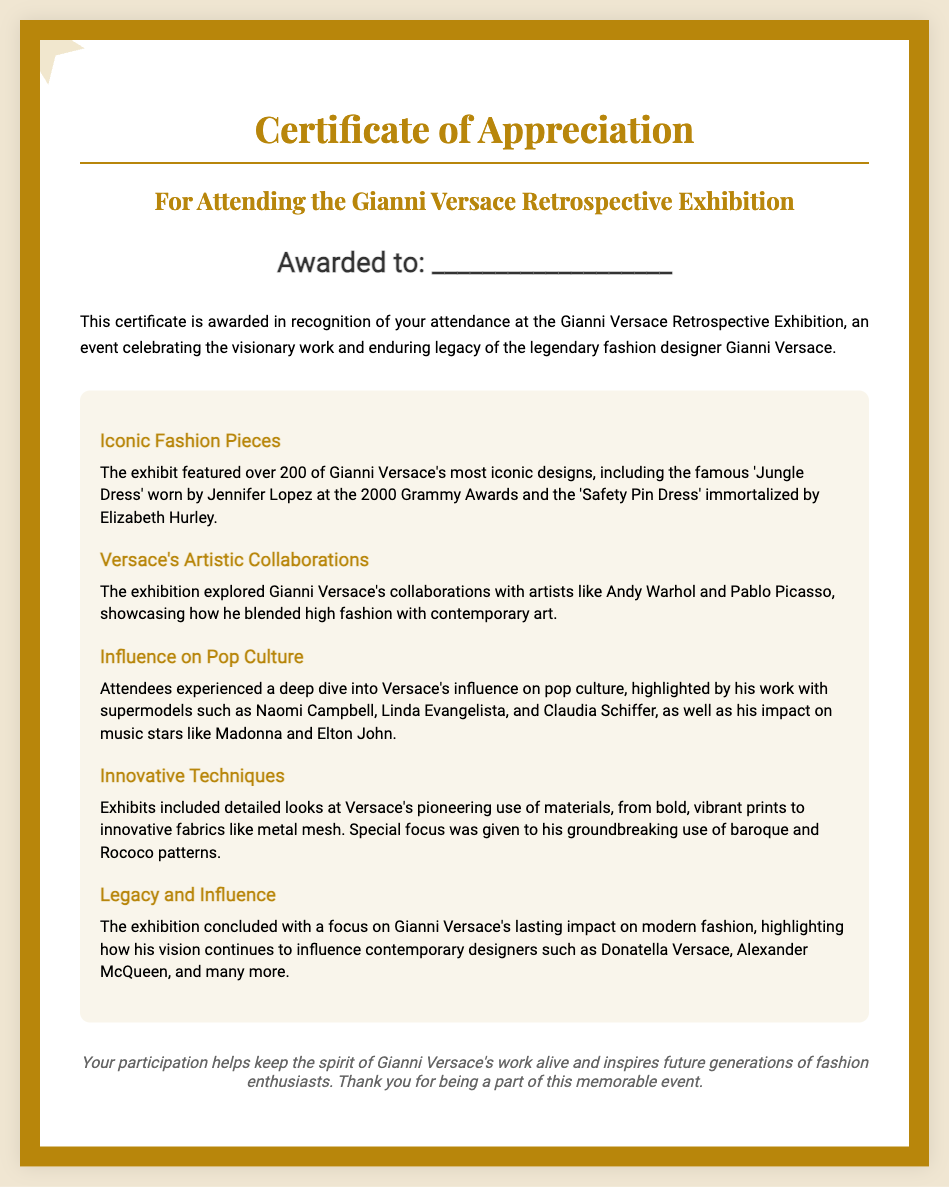What is the title of the exhibition? The title of the exhibition is mentioned directly in the certificate title: "Gianni Versace Retrospective Exhibition."
Answer: Gianni Versace Retrospective Exhibition How many iconic designs were featured in the exhibit? The document provides a specific number of designs showcased, which is over 200.
Answer: over 200 Who wore the 'Jungle Dress' at the 2000 Grammy Awards? The document specifies that Jennifer Lopez wore the 'Jungle Dress' at that event.
Answer: Jennifer Lopez What artistic collaborations are highlighted in the exhibition? The document lists notable artists collaborated with Versace, specifically mentioning Andy Warhol and Pablo Picasso.
Answer: Andy Warhol and Pablo Picasso What type of techniques did Versace pioneer? The document describes the techniques as innovative, particularly in materials and patterns.
Answer: Innovative techniques Who are some of the supermodels associated with Versace's work? The exhibition highlights supermodels, naming Naomi Campbell, Linda Evangelista, and Claudia Schiffer.
Answer: Naomi Campbell, Linda Evangelista, Claudia Schiffer What is the purpose of the certificate? The certificate's purpose is to recognize attendance at the event celebrating Gianni Versace's legacy.
Answer: Recognize attendance What impact does the document mention regarding Gianni Versace's influence? The document mentions Versace's lasting impact on modern fashion and contemporary designers.
Answer: Lasting impact on modern fashion What is the closing message of the certificate? The closing message expresses gratitude and acknowledges the participant's role in keeping Versace's spirit alive.
Answer: Thank you for being a part of this memorable event 